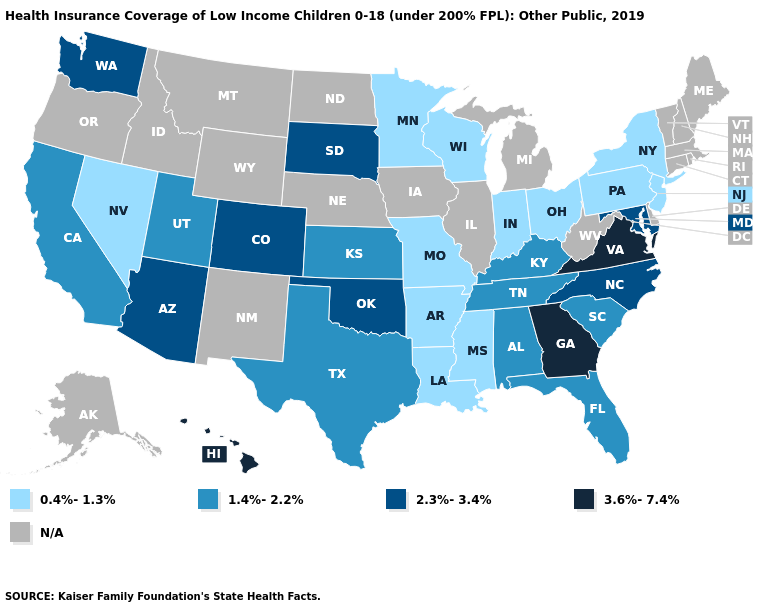Name the states that have a value in the range 2.3%-3.4%?
Short answer required. Arizona, Colorado, Maryland, North Carolina, Oklahoma, South Dakota, Washington. Which states have the lowest value in the MidWest?
Write a very short answer. Indiana, Minnesota, Missouri, Ohio, Wisconsin. What is the highest value in the MidWest ?
Give a very brief answer. 2.3%-3.4%. Name the states that have a value in the range 0.4%-1.3%?
Be succinct. Arkansas, Indiana, Louisiana, Minnesota, Mississippi, Missouri, Nevada, New Jersey, New York, Ohio, Pennsylvania, Wisconsin. Which states have the highest value in the USA?
Concise answer only. Georgia, Hawaii, Virginia. Name the states that have a value in the range 2.3%-3.4%?
Quick response, please. Arizona, Colorado, Maryland, North Carolina, Oklahoma, South Dakota, Washington. How many symbols are there in the legend?
Write a very short answer. 5. What is the highest value in the USA?
Concise answer only. 3.6%-7.4%. What is the highest value in states that border Maryland?
Give a very brief answer. 3.6%-7.4%. Name the states that have a value in the range N/A?
Quick response, please. Alaska, Connecticut, Delaware, Idaho, Illinois, Iowa, Maine, Massachusetts, Michigan, Montana, Nebraska, New Hampshire, New Mexico, North Dakota, Oregon, Rhode Island, Vermont, West Virginia, Wyoming. Name the states that have a value in the range 0.4%-1.3%?
Short answer required. Arkansas, Indiana, Louisiana, Minnesota, Mississippi, Missouri, Nevada, New Jersey, New York, Ohio, Pennsylvania, Wisconsin. 